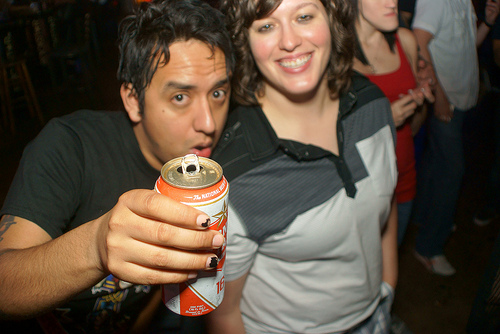<image>
Is the man in front of the women? No. The man is not in front of the women. The spatial positioning shows a different relationship between these objects. 